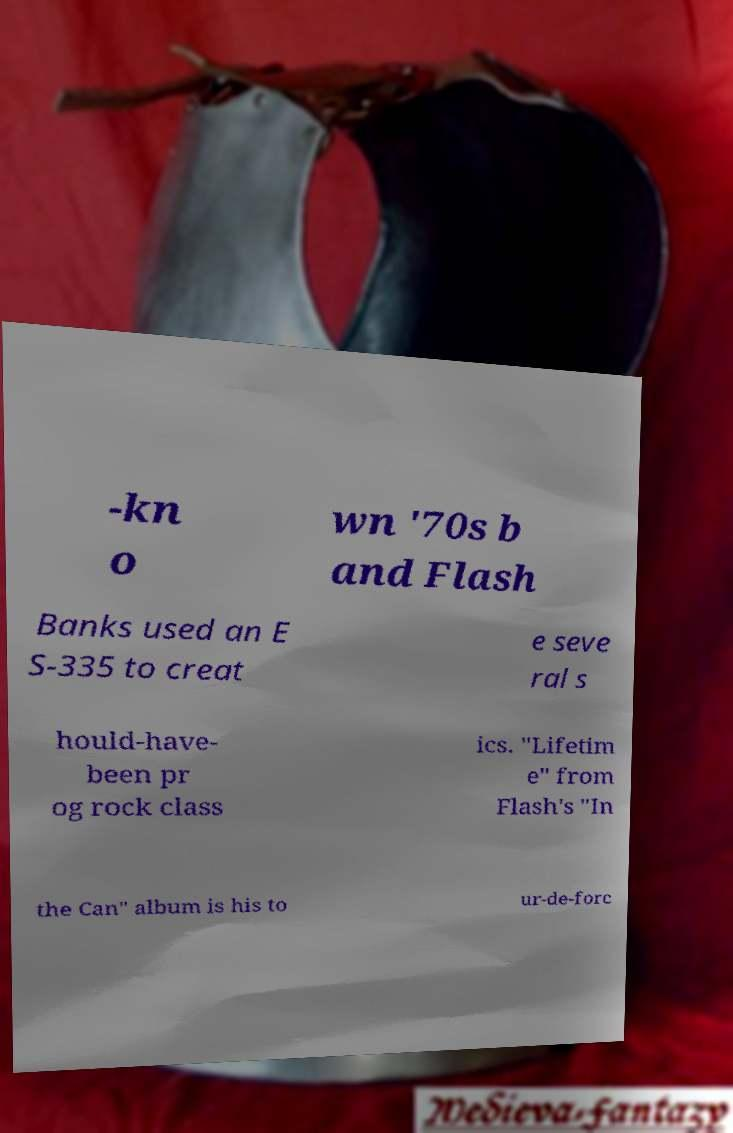For documentation purposes, I need the text within this image transcribed. Could you provide that? -kn o wn '70s b and Flash Banks used an E S-335 to creat e seve ral s hould-have- been pr og rock class ics. "Lifetim e" from Flash's "In the Can" album is his to ur-de-forc 